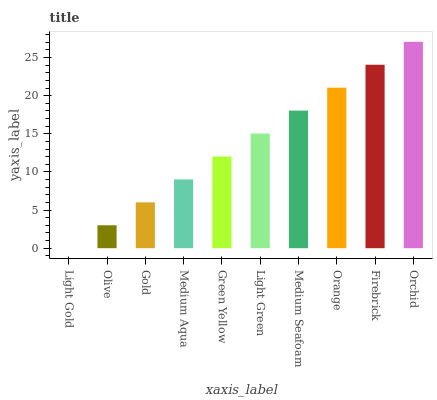Is Light Gold the minimum?
Answer yes or no. Yes. Is Orchid the maximum?
Answer yes or no. Yes. Is Olive the minimum?
Answer yes or no. No. Is Olive the maximum?
Answer yes or no. No. Is Olive greater than Light Gold?
Answer yes or no. Yes. Is Light Gold less than Olive?
Answer yes or no. Yes. Is Light Gold greater than Olive?
Answer yes or no. No. Is Olive less than Light Gold?
Answer yes or no. No. Is Light Green the high median?
Answer yes or no. Yes. Is Green Yellow the low median?
Answer yes or no. Yes. Is Medium Seafoam the high median?
Answer yes or no. No. Is Orchid the low median?
Answer yes or no. No. 